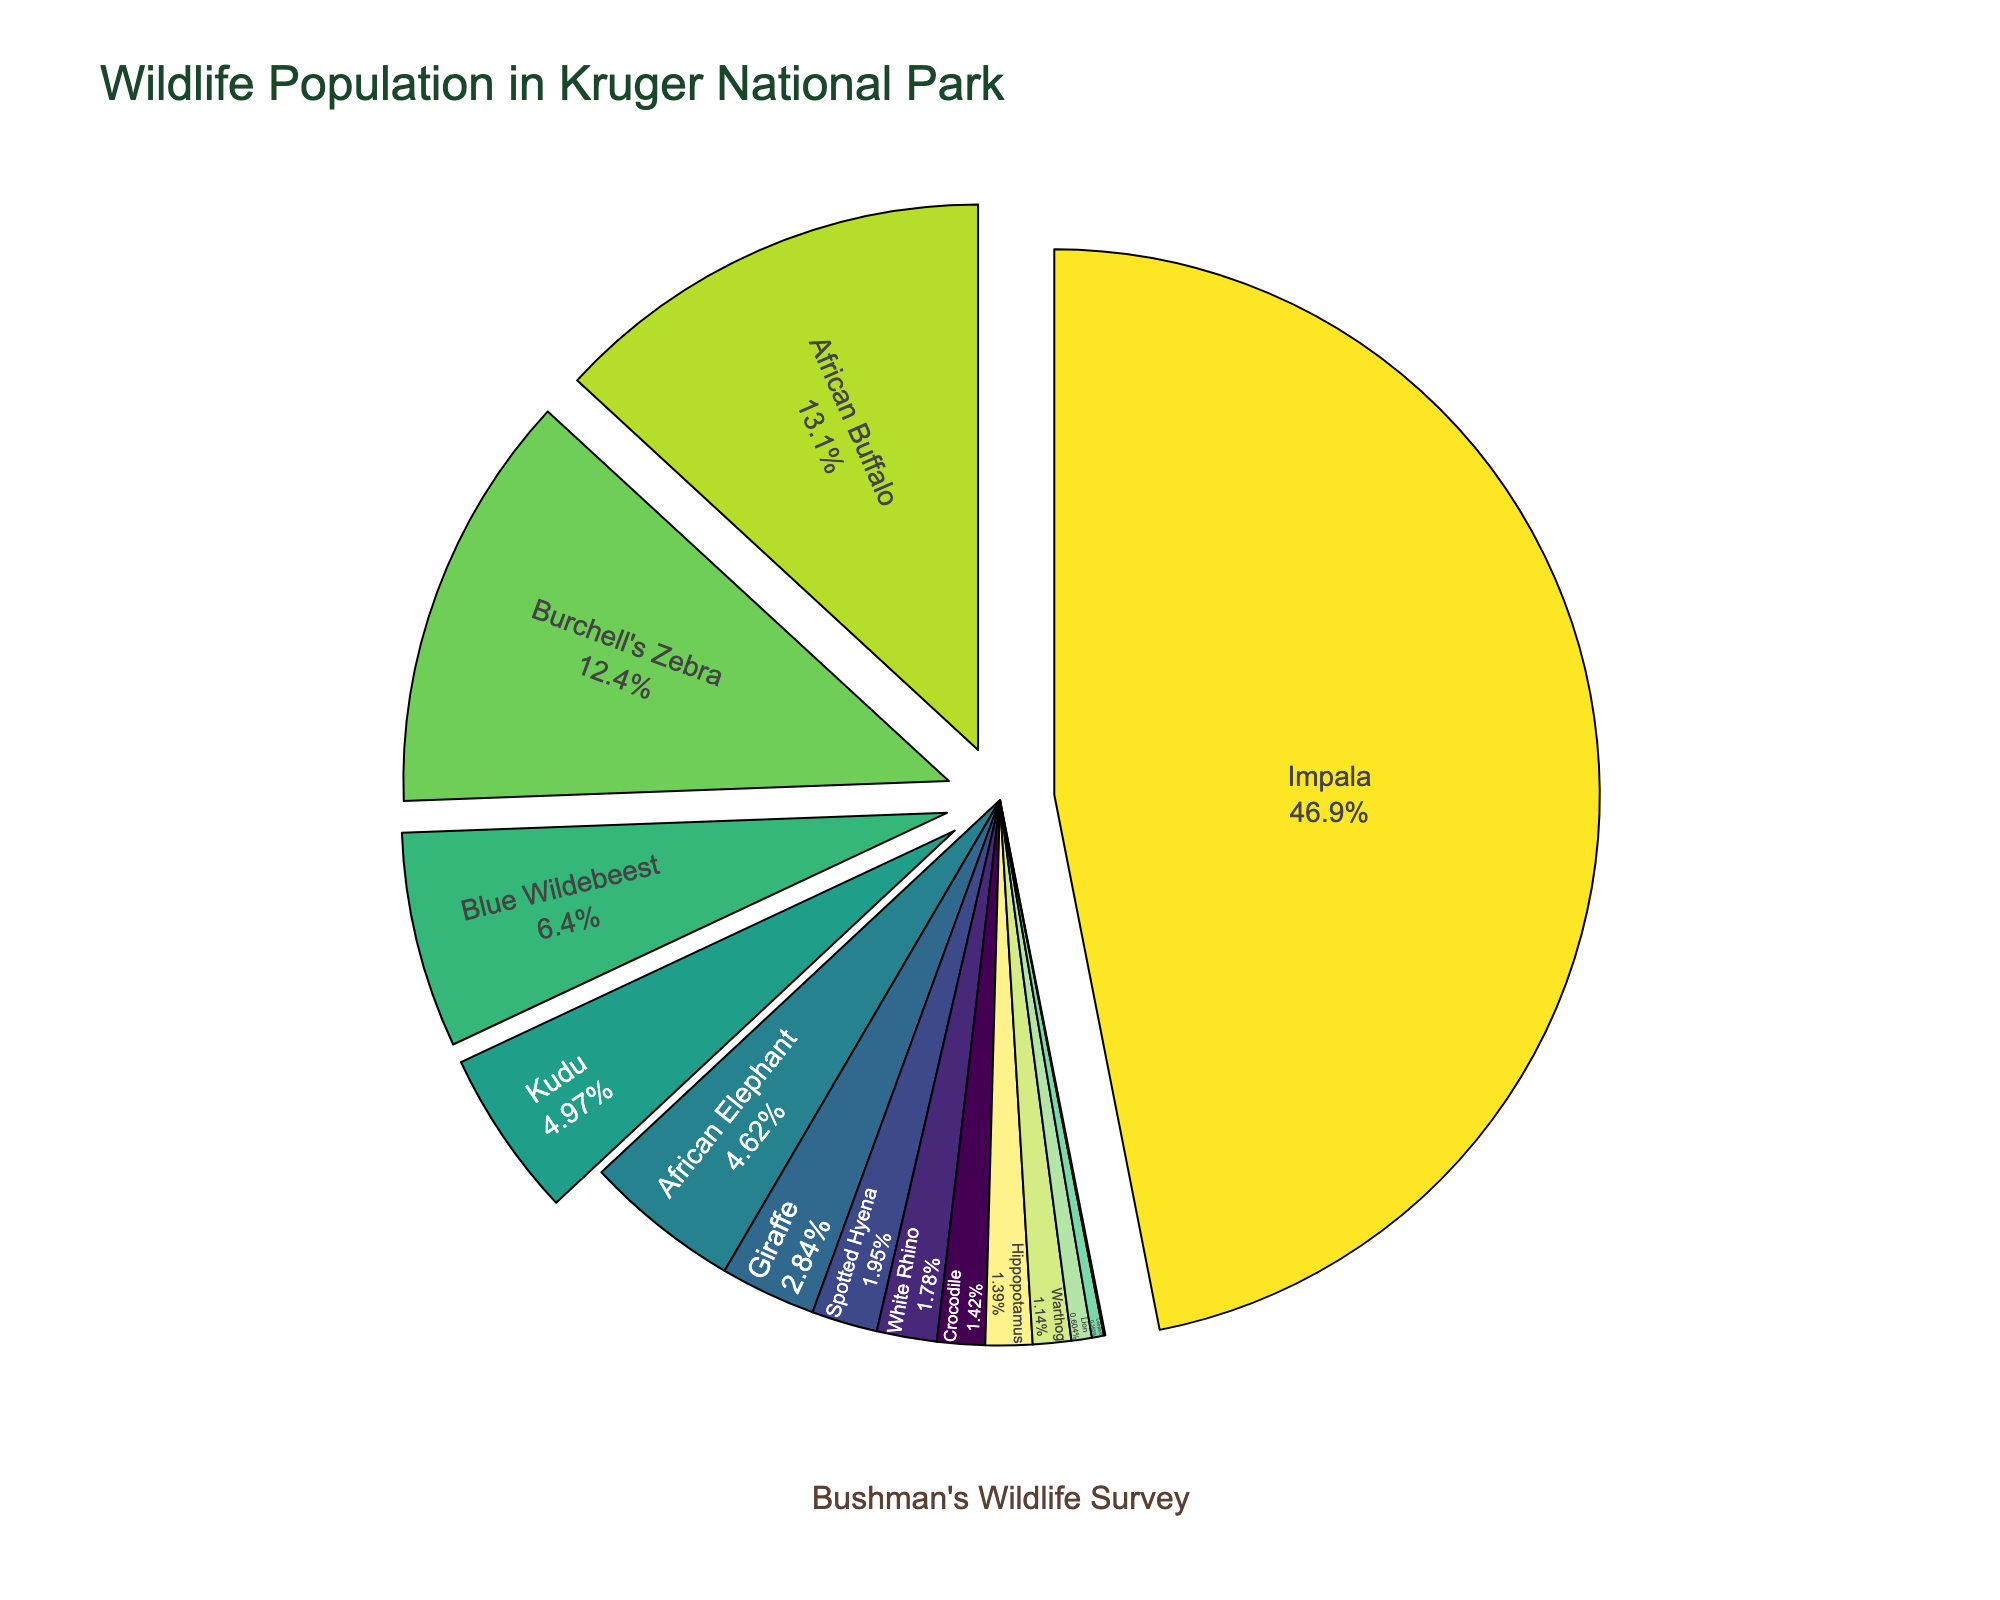What is the species with the largest population? The figure shows the populations of various species in Kruger National Park. The species with the largest section of the pie chart and thus the largest population is Impala.
Answer: Impala What are the top three species by population? By visually inspecting the pie chart, we can see that the top three species by population are the ones with the largest segments. The Impala has the largest segment, followed by Burchell's Zebra, and then African Buffalo.
Answer: Impala, Burchell's Zebra, African Buffalo Which species have populations less than 5,000? From the segments of the pie chart, we identify that species with smaller sections than the White Rhino's seem to fit the criteria. Upon closer inspection, Warthog, Lion, Leopard, Cheetah, Spotted Hyena, Hippopotamus, and Crocodile are all smaller segments than White Rhino.
Answer: Lion, Leopard, Cheetah Combine the populations of the African Elephant and the Giraffe. What part of the total population does this represent? From the pie chart, the population of the African Elephant is 13,000 and the Giraffe is 8,000. Summing these gives 21,000. To find the percentage, we divide 21,000 by the total population (when all segments sum up) and multiply by 100.
Answer: 8.68% What is the difference in population between the Cheetah and Leopard? We find the population numbers from the pie chart segments, where the Leopard has 1,000 individuals and the Cheetah has 120 individuals. The difference is calculated as 1,000 - 120.
Answer: 880 How many species have a population greater than 10,000? By examining the pie chart, we see that the segments corresponding to a population greater than 10,000 include African Elephant, Impala, Burchell's Zebra, Blue Wildebeest, and African Buffalo.
Answer: 5 Which species appears to be the least common in Kruger National Park? From visually inspecting the pie chart, the species with the smallest section is identified as the Cheetah.
Answer: Cheetah Rank the White Rhino, Blue Wildebeest, and Kudu by their population sizes? Referring to the pie chart, the populations of the White Rhino, Blue Wildebeest, and Kudu are identified. Blue Wildebeest has 18,000, Kudu has 14,000, and White Rhino has 5,000. Ranking them from highest to lowest, we have Blue Wildebeest, Kudu, and then White Rhino.
Answer: Blue Wildebeest, Kudu, White Rhino What fraction of the animal population does the Blue Wildebeest and Burchell's Zebra together comprise? The Blue Wildebeest has a population of 18,000 and the Burchell’s Zebra is 35,000. Adding these, we get 53,000. To find the fraction of the total population, we divide 53,000 by the total population.
Answer: 5.44% 